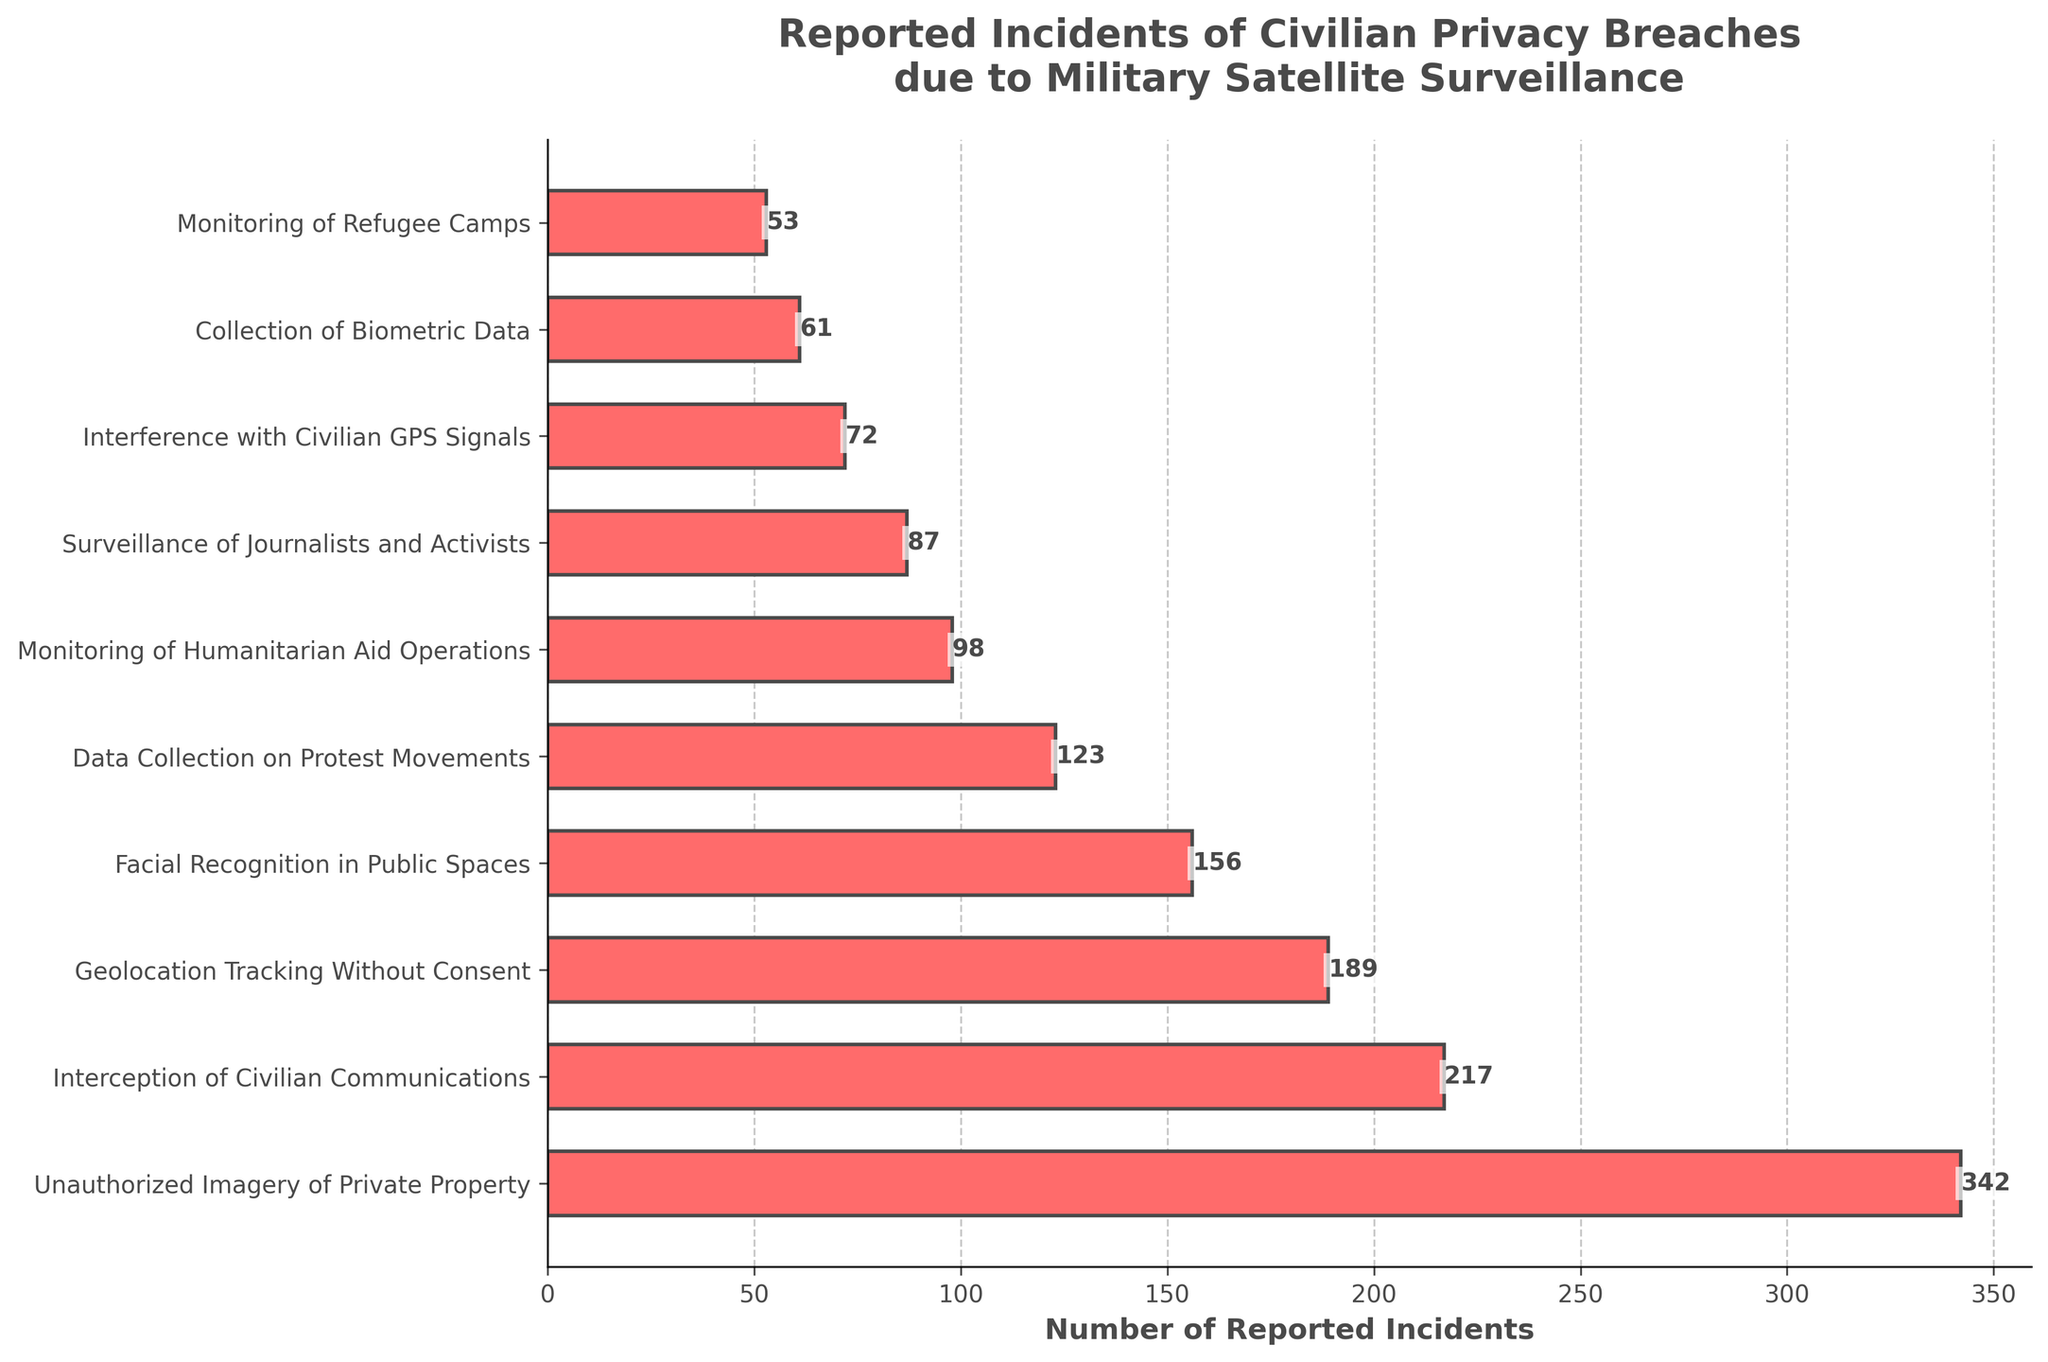What's the total number of reported incidents across all types of breaches? To find the total number of reported incidents, sum all the individual counts: 342 + 217 + 189 + 156 + 123 + 98 + 87 + 72 + 61 + 53 = 1,398
Answer: 1,398 Which type of breach has the highest number of reported incidents? The highest bar in the chart represents the "Unauthorized Imagery of Private Property" with 342 incidents
Answer: Unauthorized Imagery of Private Property How many more incidents are reported for "Interception of Civilian Communications" compared to "Surveillance of Journalists and Activists"? Subtract the number of incidents of Surveillance of Journalists and Activists (87) from Interception of Civilian Communications (217), which is 217 - 87 = 130
Answer: 130 What is the average number of reported incidents across all types of breaches? Total number of incidents is 1,398. There are 10 types of breaches. Average is 1,398 / 10 = 139.8
Answer: 139.8 Are there more reported incidents of "Data Collection on Protest Movements" or "Facial Recognition in Public Spaces"? Compare the numbers directly: Data Collection on Protest Movements (123) vs Facial Recognition in Public Spaces (156). 156 is greater than 123
Answer: Facial Recognition in Public Spaces What's the combined number of incidents for the three least reported types of breaches? The three least reported types are Monitoring of Refugee Camps (53), Collection of Biometric Data (61), and Interference with Civilian GPS Signals (72). Combined is 53 + 61 + 72 = 186
Answer: 186 Which breach type is reported more frequently than "Geolocation Tracking Without Consent" but less frequently than "Interception of Civilian Communications"? Between Geolocation Tracking Without Consent (189) and Interception of Civilian Communications (217), the only fitting type is Facial Recognition in Public Spaces with 156 incidents
Answer: Facial Recognition in Public Spaces What is the total number of incidents reported for "Monitoring of Humanitarian Aid Operations" and "Surveillance of Journalists and Activists"? Add the values for both types: Monitoring of Humanitarian Aid Operations (98) + Surveillance of Journalists and Activists (87) = 185
Answer: 185 Which category has incident numbers closest to the overall average? The overall average is 139.8. Compare it to individual breaches: Geolocation Tracking Without Consent (189) is the closest to 139.8
Answer: Geolocation Tracking Without Consent 